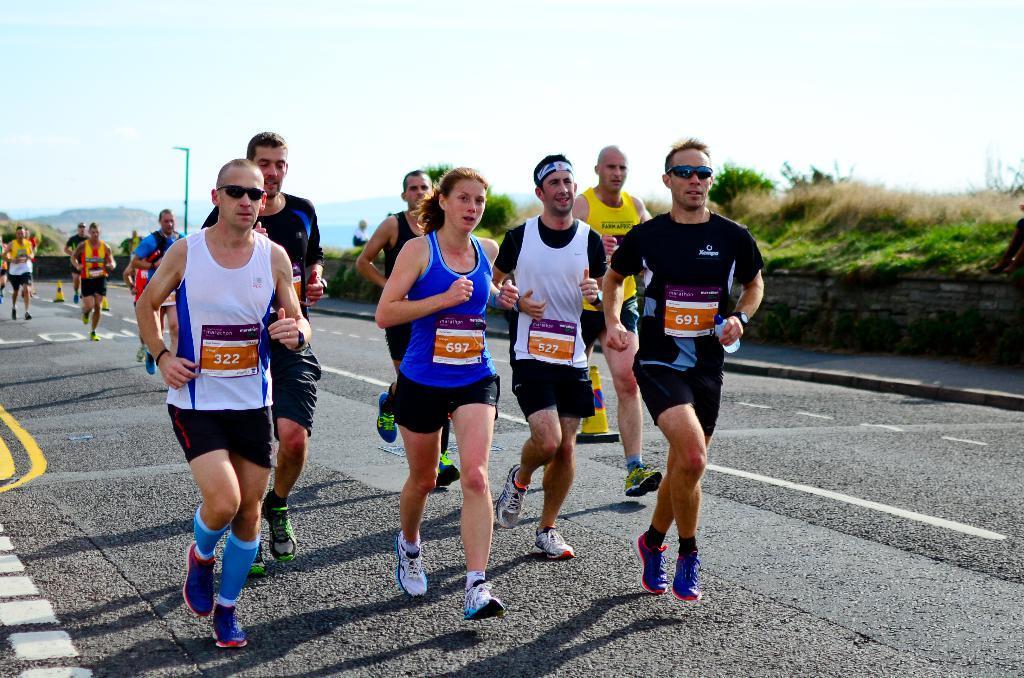How would you summarize this image in a sentence or two? In this image people are running on the road. At the right side of the image there is a grass on the surface and at the background there is a street light. There are mountains and sky. 